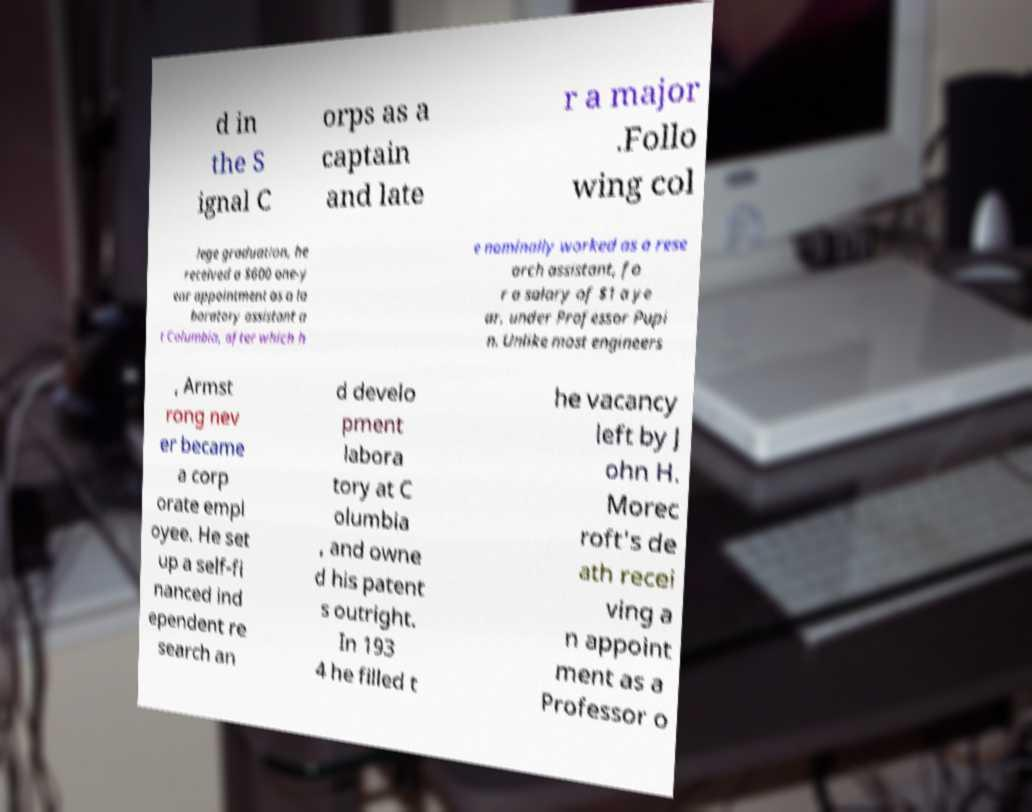What messages or text are displayed in this image? I need them in a readable, typed format. d in the S ignal C orps as a captain and late r a major .Follo wing col lege graduation, he received a $600 one-y ear appointment as a la boratory assistant a t Columbia, after which h e nominally worked as a rese arch assistant, fo r a salary of $1 a ye ar, under Professor Pupi n. Unlike most engineers , Armst rong nev er became a corp orate empl oyee. He set up a self-fi nanced ind ependent re search an d develo pment labora tory at C olumbia , and owne d his patent s outright. In 193 4 he filled t he vacancy left by J ohn H. Morec roft's de ath recei ving a n appoint ment as a Professor o 